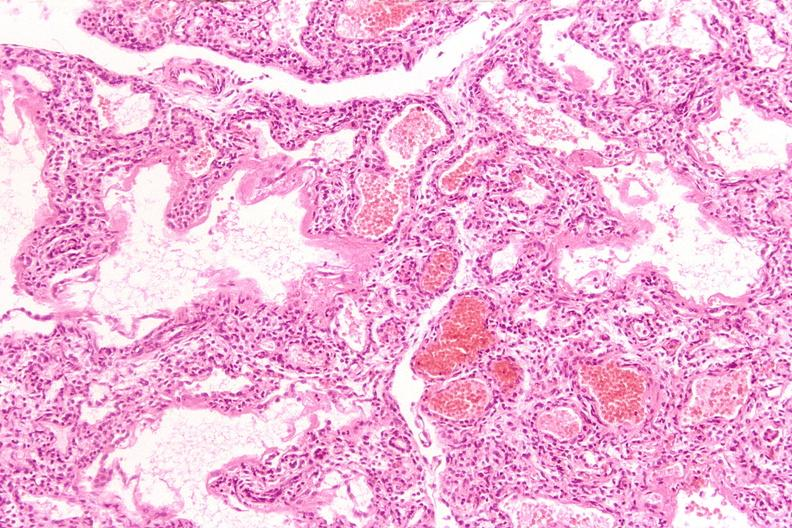what is present?
Answer the question using a single word or phrase. Respiratory 